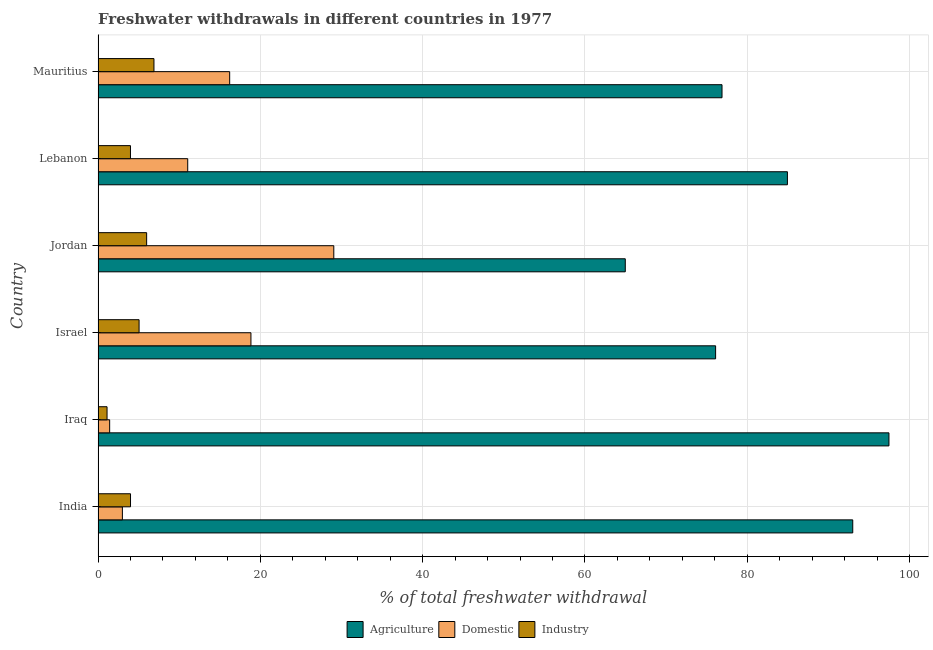How many groups of bars are there?
Offer a very short reply. 6. Are the number of bars per tick equal to the number of legend labels?
Ensure brevity in your answer.  Yes. Are the number of bars on each tick of the Y-axis equal?
Provide a succinct answer. Yes. How many bars are there on the 3rd tick from the bottom?
Offer a terse response. 3. What is the label of the 3rd group of bars from the top?
Ensure brevity in your answer.  Jordan. What is the percentage of freshwater withdrawal for agriculture in Iraq?
Make the answer very short. 97.46. Across all countries, what is the maximum percentage of freshwater withdrawal for industry?
Your response must be concise. 6.89. Across all countries, what is the minimum percentage of freshwater withdrawal for agriculture?
Provide a short and direct response. 64.97. In which country was the percentage of freshwater withdrawal for industry maximum?
Your answer should be very brief. Mauritius. In which country was the percentage of freshwater withdrawal for industry minimum?
Give a very brief answer. Iraq. What is the total percentage of freshwater withdrawal for industry in the graph?
Offer a very short reply. 27.03. What is the difference between the percentage of freshwater withdrawal for industry in India and that in Iraq?
Your answer should be very brief. 2.89. What is the difference between the percentage of freshwater withdrawal for domestic purposes in Iraq and the percentage of freshwater withdrawal for agriculture in India?
Give a very brief answer. -91.57. What is the average percentage of freshwater withdrawal for agriculture per country?
Your answer should be compact. 82.23. What is the difference between the percentage of freshwater withdrawal for domestic purposes and percentage of freshwater withdrawal for agriculture in Mauritius?
Provide a succinct answer. -60.67. In how many countries, is the percentage of freshwater withdrawal for industry greater than 44 %?
Ensure brevity in your answer.  0. What is the ratio of the percentage of freshwater withdrawal for industry in Jordan to that in Mauritius?
Give a very brief answer. 0.87. Is the difference between the percentage of freshwater withdrawal for industry in Lebanon and Mauritius greater than the difference between the percentage of freshwater withdrawal for domestic purposes in Lebanon and Mauritius?
Your answer should be very brief. Yes. What is the difference between the highest and the second highest percentage of freshwater withdrawal for domestic purposes?
Provide a short and direct response. 10.21. What is the difference between the highest and the lowest percentage of freshwater withdrawal for agriculture?
Your answer should be very brief. 32.49. In how many countries, is the percentage of freshwater withdrawal for domestic purposes greater than the average percentage of freshwater withdrawal for domestic purposes taken over all countries?
Provide a short and direct response. 3. Is the sum of the percentage of freshwater withdrawal for agriculture in Iraq and Israel greater than the maximum percentage of freshwater withdrawal for industry across all countries?
Offer a terse response. Yes. What does the 1st bar from the top in Lebanon represents?
Your answer should be very brief. Industry. What does the 2nd bar from the bottom in Israel represents?
Your answer should be compact. Domestic. How many bars are there?
Ensure brevity in your answer.  18. Are all the bars in the graph horizontal?
Ensure brevity in your answer.  Yes. How many countries are there in the graph?
Your answer should be compact. 6. What is the difference between two consecutive major ticks on the X-axis?
Your answer should be very brief. 20. Are the values on the major ticks of X-axis written in scientific E-notation?
Make the answer very short. No. Does the graph contain grids?
Ensure brevity in your answer.  Yes. What is the title of the graph?
Your answer should be very brief. Freshwater withdrawals in different countries in 1977. What is the label or title of the X-axis?
Provide a short and direct response. % of total freshwater withdrawal. What is the % of total freshwater withdrawal of Agriculture in India?
Make the answer very short. 93. What is the % of total freshwater withdrawal of Industry in India?
Keep it short and to the point. 4. What is the % of total freshwater withdrawal in Agriculture in Iraq?
Give a very brief answer. 97.46. What is the % of total freshwater withdrawal in Domestic in Iraq?
Give a very brief answer. 1.43. What is the % of total freshwater withdrawal of Industry in Iraq?
Provide a succinct answer. 1.11. What is the % of total freshwater withdrawal of Agriculture in Israel?
Your response must be concise. 76.1. What is the % of total freshwater withdrawal in Domestic in Israel?
Your answer should be very brief. 18.84. What is the % of total freshwater withdrawal of Industry in Israel?
Offer a very short reply. 5.05. What is the % of total freshwater withdrawal in Agriculture in Jordan?
Make the answer very short. 64.97. What is the % of total freshwater withdrawal in Domestic in Jordan?
Provide a succinct answer. 29.05. What is the % of total freshwater withdrawal of Industry in Jordan?
Give a very brief answer. 5.99. What is the % of total freshwater withdrawal in Agriculture in Lebanon?
Ensure brevity in your answer.  84.95. What is the % of total freshwater withdrawal of Domestic in Lebanon?
Your answer should be compact. 11.05. What is the % of total freshwater withdrawal of Industry in Lebanon?
Your answer should be compact. 4. What is the % of total freshwater withdrawal in Agriculture in Mauritius?
Provide a short and direct response. 76.89. What is the % of total freshwater withdrawal of Domestic in Mauritius?
Your response must be concise. 16.22. What is the % of total freshwater withdrawal in Industry in Mauritius?
Provide a short and direct response. 6.89. Across all countries, what is the maximum % of total freshwater withdrawal in Agriculture?
Provide a short and direct response. 97.46. Across all countries, what is the maximum % of total freshwater withdrawal of Domestic?
Ensure brevity in your answer.  29.05. Across all countries, what is the maximum % of total freshwater withdrawal of Industry?
Your answer should be very brief. 6.89. Across all countries, what is the minimum % of total freshwater withdrawal of Agriculture?
Ensure brevity in your answer.  64.97. Across all countries, what is the minimum % of total freshwater withdrawal in Domestic?
Your response must be concise. 1.43. Across all countries, what is the minimum % of total freshwater withdrawal of Industry?
Offer a very short reply. 1.11. What is the total % of total freshwater withdrawal of Agriculture in the graph?
Ensure brevity in your answer.  493.37. What is the total % of total freshwater withdrawal in Domestic in the graph?
Your answer should be compact. 79.59. What is the total % of total freshwater withdrawal in Industry in the graph?
Your answer should be very brief. 27.04. What is the difference between the % of total freshwater withdrawal of Agriculture in India and that in Iraq?
Your response must be concise. -4.46. What is the difference between the % of total freshwater withdrawal in Domestic in India and that in Iraq?
Your answer should be very brief. 1.57. What is the difference between the % of total freshwater withdrawal in Industry in India and that in Iraq?
Offer a very short reply. 2.89. What is the difference between the % of total freshwater withdrawal in Domestic in India and that in Israel?
Ensure brevity in your answer.  -15.84. What is the difference between the % of total freshwater withdrawal in Industry in India and that in Israel?
Make the answer very short. -1.05. What is the difference between the % of total freshwater withdrawal in Agriculture in India and that in Jordan?
Offer a very short reply. 28.03. What is the difference between the % of total freshwater withdrawal in Domestic in India and that in Jordan?
Ensure brevity in your answer.  -26.05. What is the difference between the % of total freshwater withdrawal in Industry in India and that in Jordan?
Make the answer very short. -1.99. What is the difference between the % of total freshwater withdrawal in Agriculture in India and that in Lebanon?
Your answer should be very brief. 8.05. What is the difference between the % of total freshwater withdrawal in Domestic in India and that in Lebanon?
Ensure brevity in your answer.  -8.05. What is the difference between the % of total freshwater withdrawal of Industry in India and that in Lebanon?
Ensure brevity in your answer.  0.01. What is the difference between the % of total freshwater withdrawal in Agriculture in India and that in Mauritius?
Your response must be concise. 16.11. What is the difference between the % of total freshwater withdrawal in Domestic in India and that in Mauritius?
Offer a very short reply. -13.22. What is the difference between the % of total freshwater withdrawal of Industry in India and that in Mauritius?
Give a very brief answer. -2.89. What is the difference between the % of total freshwater withdrawal of Agriculture in Iraq and that in Israel?
Provide a succinct answer. 21.36. What is the difference between the % of total freshwater withdrawal of Domestic in Iraq and that in Israel?
Your response must be concise. -17.41. What is the difference between the % of total freshwater withdrawal of Industry in Iraq and that in Israel?
Your answer should be very brief. -3.95. What is the difference between the % of total freshwater withdrawal of Agriculture in Iraq and that in Jordan?
Offer a terse response. 32.49. What is the difference between the % of total freshwater withdrawal in Domestic in Iraq and that in Jordan?
Give a very brief answer. -27.62. What is the difference between the % of total freshwater withdrawal of Industry in Iraq and that in Jordan?
Give a very brief answer. -4.88. What is the difference between the % of total freshwater withdrawal in Agriculture in Iraq and that in Lebanon?
Keep it short and to the point. 12.51. What is the difference between the % of total freshwater withdrawal of Domestic in Iraq and that in Lebanon?
Provide a succinct answer. -9.62. What is the difference between the % of total freshwater withdrawal in Industry in Iraq and that in Lebanon?
Offer a terse response. -2.89. What is the difference between the % of total freshwater withdrawal of Agriculture in Iraq and that in Mauritius?
Offer a terse response. 20.57. What is the difference between the % of total freshwater withdrawal of Domestic in Iraq and that in Mauritius?
Keep it short and to the point. -14.79. What is the difference between the % of total freshwater withdrawal of Industry in Iraq and that in Mauritius?
Your answer should be compact. -5.78. What is the difference between the % of total freshwater withdrawal of Agriculture in Israel and that in Jordan?
Make the answer very short. 11.13. What is the difference between the % of total freshwater withdrawal of Domestic in Israel and that in Jordan?
Provide a succinct answer. -10.21. What is the difference between the % of total freshwater withdrawal of Industry in Israel and that in Jordan?
Your response must be concise. -0.93. What is the difference between the % of total freshwater withdrawal of Agriculture in Israel and that in Lebanon?
Your response must be concise. -8.85. What is the difference between the % of total freshwater withdrawal in Domestic in Israel and that in Lebanon?
Ensure brevity in your answer.  7.79. What is the difference between the % of total freshwater withdrawal in Industry in Israel and that in Lebanon?
Provide a succinct answer. 1.06. What is the difference between the % of total freshwater withdrawal of Agriculture in Israel and that in Mauritius?
Your answer should be very brief. -0.79. What is the difference between the % of total freshwater withdrawal in Domestic in Israel and that in Mauritius?
Your answer should be compact. 2.62. What is the difference between the % of total freshwater withdrawal of Industry in Israel and that in Mauritius?
Your answer should be compact. -1.83. What is the difference between the % of total freshwater withdrawal of Agriculture in Jordan and that in Lebanon?
Offer a very short reply. -19.98. What is the difference between the % of total freshwater withdrawal of Domestic in Jordan and that in Lebanon?
Offer a terse response. 18. What is the difference between the % of total freshwater withdrawal in Industry in Jordan and that in Lebanon?
Your answer should be very brief. 1.99. What is the difference between the % of total freshwater withdrawal in Agriculture in Jordan and that in Mauritius?
Give a very brief answer. -11.92. What is the difference between the % of total freshwater withdrawal in Domestic in Jordan and that in Mauritius?
Keep it short and to the point. 12.83. What is the difference between the % of total freshwater withdrawal in Industry in Jordan and that in Mauritius?
Provide a short and direct response. -0.9. What is the difference between the % of total freshwater withdrawal in Agriculture in Lebanon and that in Mauritius?
Your answer should be very brief. 8.06. What is the difference between the % of total freshwater withdrawal in Domestic in Lebanon and that in Mauritius?
Provide a short and direct response. -5.17. What is the difference between the % of total freshwater withdrawal of Industry in Lebanon and that in Mauritius?
Offer a very short reply. -2.89. What is the difference between the % of total freshwater withdrawal of Agriculture in India and the % of total freshwater withdrawal of Domestic in Iraq?
Offer a terse response. 91.57. What is the difference between the % of total freshwater withdrawal of Agriculture in India and the % of total freshwater withdrawal of Industry in Iraq?
Your answer should be compact. 91.89. What is the difference between the % of total freshwater withdrawal of Domestic in India and the % of total freshwater withdrawal of Industry in Iraq?
Make the answer very short. 1.89. What is the difference between the % of total freshwater withdrawal of Agriculture in India and the % of total freshwater withdrawal of Domestic in Israel?
Ensure brevity in your answer.  74.16. What is the difference between the % of total freshwater withdrawal of Agriculture in India and the % of total freshwater withdrawal of Industry in Israel?
Your answer should be very brief. 87.94. What is the difference between the % of total freshwater withdrawal of Domestic in India and the % of total freshwater withdrawal of Industry in Israel?
Offer a very short reply. -2.06. What is the difference between the % of total freshwater withdrawal in Agriculture in India and the % of total freshwater withdrawal in Domestic in Jordan?
Your answer should be compact. 63.95. What is the difference between the % of total freshwater withdrawal in Agriculture in India and the % of total freshwater withdrawal in Industry in Jordan?
Offer a very short reply. 87.01. What is the difference between the % of total freshwater withdrawal in Domestic in India and the % of total freshwater withdrawal in Industry in Jordan?
Ensure brevity in your answer.  -2.99. What is the difference between the % of total freshwater withdrawal of Agriculture in India and the % of total freshwater withdrawal of Domestic in Lebanon?
Your answer should be compact. 81.95. What is the difference between the % of total freshwater withdrawal in Agriculture in India and the % of total freshwater withdrawal in Industry in Lebanon?
Provide a short and direct response. 89. What is the difference between the % of total freshwater withdrawal in Domestic in India and the % of total freshwater withdrawal in Industry in Lebanon?
Ensure brevity in your answer.  -0.99. What is the difference between the % of total freshwater withdrawal in Agriculture in India and the % of total freshwater withdrawal in Domestic in Mauritius?
Your answer should be very brief. 76.78. What is the difference between the % of total freshwater withdrawal of Agriculture in India and the % of total freshwater withdrawal of Industry in Mauritius?
Offer a terse response. 86.11. What is the difference between the % of total freshwater withdrawal of Domestic in India and the % of total freshwater withdrawal of Industry in Mauritius?
Keep it short and to the point. -3.89. What is the difference between the % of total freshwater withdrawal of Agriculture in Iraq and the % of total freshwater withdrawal of Domestic in Israel?
Offer a very short reply. 78.62. What is the difference between the % of total freshwater withdrawal in Agriculture in Iraq and the % of total freshwater withdrawal in Industry in Israel?
Keep it short and to the point. 92.41. What is the difference between the % of total freshwater withdrawal in Domestic in Iraq and the % of total freshwater withdrawal in Industry in Israel?
Give a very brief answer. -3.62. What is the difference between the % of total freshwater withdrawal in Agriculture in Iraq and the % of total freshwater withdrawal in Domestic in Jordan?
Offer a terse response. 68.41. What is the difference between the % of total freshwater withdrawal of Agriculture in Iraq and the % of total freshwater withdrawal of Industry in Jordan?
Ensure brevity in your answer.  91.47. What is the difference between the % of total freshwater withdrawal of Domestic in Iraq and the % of total freshwater withdrawal of Industry in Jordan?
Keep it short and to the point. -4.56. What is the difference between the % of total freshwater withdrawal of Agriculture in Iraq and the % of total freshwater withdrawal of Domestic in Lebanon?
Give a very brief answer. 86.41. What is the difference between the % of total freshwater withdrawal of Agriculture in Iraq and the % of total freshwater withdrawal of Industry in Lebanon?
Provide a short and direct response. 93.47. What is the difference between the % of total freshwater withdrawal in Domestic in Iraq and the % of total freshwater withdrawal in Industry in Lebanon?
Keep it short and to the point. -2.56. What is the difference between the % of total freshwater withdrawal of Agriculture in Iraq and the % of total freshwater withdrawal of Domestic in Mauritius?
Your answer should be very brief. 81.24. What is the difference between the % of total freshwater withdrawal in Agriculture in Iraq and the % of total freshwater withdrawal in Industry in Mauritius?
Offer a terse response. 90.57. What is the difference between the % of total freshwater withdrawal of Domestic in Iraq and the % of total freshwater withdrawal of Industry in Mauritius?
Offer a terse response. -5.46. What is the difference between the % of total freshwater withdrawal in Agriculture in Israel and the % of total freshwater withdrawal in Domestic in Jordan?
Keep it short and to the point. 47.05. What is the difference between the % of total freshwater withdrawal in Agriculture in Israel and the % of total freshwater withdrawal in Industry in Jordan?
Provide a succinct answer. 70.11. What is the difference between the % of total freshwater withdrawal of Domestic in Israel and the % of total freshwater withdrawal of Industry in Jordan?
Your response must be concise. 12.85. What is the difference between the % of total freshwater withdrawal of Agriculture in Israel and the % of total freshwater withdrawal of Domestic in Lebanon?
Your answer should be compact. 65.05. What is the difference between the % of total freshwater withdrawal in Agriculture in Israel and the % of total freshwater withdrawal in Industry in Lebanon?
Provide a succinct answer. 72.11. What is the difference between the % of total freshwater withdrawal of Domestic in Israel and the % of total freshwater withdrawal of Industry in Lebanon?
Offer a terse response. 14.85. What is the difference between the % of total freshwater withdrawal of Agriculture in Israel and the % of total freshwater withdrawal of Domestic in Mauritius?
Your response must be concise. 59.88. What is the difference between the % of total freshwater withdrawal in Agriculture in Israel and the % of total freshwater withdrawal in Industry in Mauritius?
Make the answer very short. 69.21. What is the difference between the % of total freshwater withdrawal in Domestic in Israel and the % of total freshwater withdrawal in Industry in Mauritius?
Provide a short and direct response. 11.95. What is the difference between the % of total freshwater withdrawal of Agriculture in Jordan and the % of total freshwater withdrawal of Domestic in Lebanon?
Your answer should be compact. 53.92. What is the difference between the % of total freshwater withdrawal of Agriculture in Jordan and the % of total freshwater withdrawal of Industry in Lebanon?
Your answer should be compact. 60.98. What is the difference between the % of total freshwater withdrawal in Domestic in Jordan and the % of total freshwater withdrawal in Industry in Lebanon?
Offer a very short reply. 25.05. What is the difference between the % of total freshwater withdrawal of Agriculture in Jordan and the % of total freshwater withdrawal of Domestic in Mauritius?
Your answer should be compact. 48.75. What is the difference between the % of total freshwater withdrawal of Agriculture in Jordan and the % of total freshwater withdrawal of Industry in Mauritius?
Ensure brevity in your answer.  58.08. What is the difference between the % of total freshwater withdrawal of Domestic in Jordan and the % of total freshwater withdrawal of Industry in Mauritius?
Offer a terse response. 22.16. What is the difference between the % of total freshwater withdrawal in Agriculture in Lebanon and the % of total freshwater withdrawal in Domestic in Mauritius?
Offer a terse response. 68.73. What is the difference between the % of total freshwater withdrawal of Agriculture in Lebanon and the % of total freshwater withdrawal of Industry in Mauritius?
Your answer should be compact. 78.06. What is the difference between the % of total freshwater withdrawal in Domestic in Lebanon and the % of total freshwater withdrawal in Industry in Mauritius?
Offer a terse response. 4.16. What is the average % of total freshwater withdrawal of Agriculture per country?
Keep it short and to the point. 82.23. What is the average % of total freshwater withdrawal of Domestic per country?
Ensure brevity in your answer.  13.27. What is the average % of total freshwater withdrawal in Industry per country?
Make the answer very short. 4.51. What is the difference between the % of total freshwater withdrawal of Agriculture and % of total freshwater withdrawal of Domestic in India?
Offer a very short reply. 90. What is the difference between the % of total freshwater withdrawal in Agriculture and % of total freshwater withdrawal in Industry in India?
Your answer should be very brief. 89. What is the difference between the % of total freshwater withdrawal of Domestic and % of total freshwater withdrawal of Industry in India?
Make the answer very short. -1. What is the difference between the % of total freshwater withdrawal in Agriculture and % of total freshwater withdrawal in Domestic in Iraq?
Your answer should be compact. 96.03. What is the difference between the % of total freshwater withdrawal in Agriculture and % of total freshwater withdrawal in Industry in Iraq?
Offer a very short reply. 96.35. What is the difference between the % of total freshwater withdrawal of Domestic and % of total freshwater withdrawal of Industry in Iraq?
Offer a terse response. 0.32. What is the difference between the % of total freshwater withdrawal of Agriculture and % of total freshwater withdrawal of Domestic in Israel?
Provide a succinct answer. 57.26. What is the difference between the % of total freshwater withdrawal of Agriculture and % of total freshwater withdrawal of Industry in Israel?
Make the answer very short. 71.05. What is the difference between the % of total freshwater withdrawal of Domestic and % of total freshwater withdrawal of Industry in Israel?
Keep it short and to the point. 13.79. What is the difference between the % of total freshwater withdrawal of Agriculture and % of total freshwater withdrawal of Domestic in Jordan?
Offer a very short reply. 35.92. What is the difference between the % of total freshwater withdrawal in Agriculture and % of total freshwater withdrawal in Industry in Jordan?
Ensure brevity in your answer.  58.98. What is the difference between the % of total freshwater withdrawal of Domestic and % of total freshwater withdrawal of Industry in Jordan?
Give a very brief answer. 23.06. What is the difference between the % of total freshwater withdrawal in Agriculture and % of total freshwater withdrawal in Domestic in Lebanon?
Your answer should be very brief. 73.9. What is the difference between the % of total freshwater withdrawal in Agriculture and % of total freshwater withdrawal in Industry in Lebanon?
Your answer should be very brief. 80.95. What is the difference between the % of total freshwater withdrawal in Domestic and % of total freshwater withdrawal in Industry in Lebanon?
Make the answer very short. 7.05. What is the difference between the % of total freshwater withdrawal in Agriculture and % of total freshwater withdrawal in Domestic in Mauritius?
Ensure brevity in your answer.  60.67. What is the difference between the % of total freshwater withdrawal in Agriculture and % of total freshwater withdrawal in Industry in Mauritius?
Make the answer very short. 70. What is the difference between the % of total freshwater withdrawal of Domestic and % of total freshwater withdrawal of Industry in Mauritius?
Your answer should be compact. 9.33. What is the ratio of the % of total freshwater withdrawal of Agriculture in India to that in Iraq?
Your response must be concise. 0.95. What is the ratio of the % of total freshwater withdrawal in Domestic in India to that in Iraq?
Offer a very short reply. 2.1. What is the ratio of the % of total freshwater withdrawal in Industry in India to that in Iraq?
Your answer should be very brief. 3.61. What is the ratio of the % of total freshwater withdrawal of Agriculture in India to that in Israel?
Your response must be concise. 1.22. What is the ratio of the % of total freshwater withdrawal in Domestic in India to that in Israel?
Offer a terse response. 0.16. What is the ratio of the % of total freshwater withdrawal of Industry in India to that in Israel?
Offer a very short reply. 0.79. What is the ratio of the % of total freshwater withdrawal of Agriculture in India to that in Jordan?
Offer a very short reply. 1.43. What is the ratio of the % of total freshwater withdrawal in Domestic in India to that in Jordan?
Offer a terse response. 0.1. What is the ratio of the % of total freshwater withdrawal in Industry in India to that in Jordan?
Make the answer very short. 0.67. What is the ratio of the % of total freshwater withdrawal of Agriculture in India to that in Lebanon?
Offer a very short reply. 1.09. What is the ratio of the % of total freshwater withdrawal of Domestic in India to that in Lebanon?
Make the answer very short. 0.27. What is the ratio of the % of total freshwater withdrawal in Agriculture in India to that in Mauritius?
Give a very brief answer. 1.21. What is the ratio of the % of total freshwater withdrawal of Domestic in India to that in Mauritius?
Provide a short and direct response. 0.18. What is the ratio of the % of total freshwater withdrawal in Industry in India to that in Mauritius?
Ensure brevity in your answer.  0.58. What is the ratio of the % of total freshwater withdrawal in Agriculture in Iraq to that in Israel?
Give a very brief answer. 1.28. What is the ratio of the % of total freshwater withdrawal in Domestic in Iraq to that in Israel?
Ensure brevity in your answer.  0.08. What is the ratio of the % of total freshwater withdrawal of Industry in Iraq to that in Israel?
Your answer should be compact. 0.22. What is the ratio of the % of total freshwater withdrawal in Agriculture in Iraq to that in Jordan?
Make the answer very short. 1.5. What is the ratio of the % of total freshwater withdrawal of Domestic in Iraq to that in Jordan?
Your answer should be very brief. 0.05. What is the ratio of the % of total freshwater withdrawal in Industry in Iraq to that in Jordan?
Make the answer very short. 0.19. What is the ratio of the % of total freshwater withdrawal in Agriculture in Iraq to that in Lebanon?
Provide a short and direct response. 1.15. What is the ratio of the % of total freshwater withdrawal of Domestic in Iraq to that in Lebanon?
Your answer should be very brief. 0.13. What is the ratio of the % of total freshwater withdrawal of Industry in Iraq to that in Lebanon?
Make the answer very short. 0.28. What is the ratio of the % of total freshwater withdrawal in Agriculture in Iraq to that in Mauritius?
Give a very brief answer. 1.27. What is the ratio of the % of total freshwater withdrawal of Domestic in Iraq to that in Mauritius?
Offer a terse response. 0.09. What is the ratio of the % of total freshwater withdrawal in Industry in Iraq to that in Mauritius?
Your answer should be very brief. 0.16. What is the ratio of the % of total freshwater withdrawal of Agriculture in Israel to that in Jordan?
Provide a succinct answer. 1.17. What is the ratio of the % of total freshwater withdrawal in Domestic in Israel to that in Jordan?
Your answer should be compact. 0.65. What is the ratio of the % of total freshwater withdrawal in Industry in Israel to that in Jordan?
Keep it short and to the point. 0.84. What is the ratio of the % of total freshwater withdrawal of Agriculture in Israel to that in Lebanon?
Your answer should be compact. 0.9. What is the ratio of the % of total freshwater withdrawal in Domestic in Israel to that in Lebanon?
Provide a short and direct response. 1.71. What is the ratio of the % of total freshwater withdrawal in Industry in Israel to that in Lebanon?
Provide a short and direct response. 1.27. What is the ratio of the % of total freshwater withdrawal in Domestic in Israel to that in Mauritius?
Your answer should be very brief. 1.16. What is the ratio of the % of total freshwater withdrawal of Industry in Israel to that in Mauritius?
Give a very brief answer. 0.73. What is the ratio of the % of total freshwater withdrawal of Agriculture in Jordan to that in Lebanon?
Offer a terse response. 0.76. What is the ratio of the % of total freshwater withdrawal of Domestic in Jordan to that in Lebanon?
Ensure brevity in your answer.  2.63. What is the ratio of the % of total freshwater withdrawal of Industry in Jordan to that in Lebanon?
Provide a succinct answer. 1.5. What is the ratio of the % of total freshwater withdrawal in Agriculture in Jordan to that in Mauritius?
Ensure brevity in your answer.  0.84. What is the ratio of the % of total freshwater withdrawal in Domestic in Jordan to that in Mauritius?
Keep it short and to the point. 1.79. What is the ratio of the % of total freshwater withdrawal of Industry in Jordan to that in Mauritius?
Keep it short and to the point. 0.87. What is the ratio of the % of total freshwater withdrawal of Agriculture in Lebanon to that in Mauritius?
Give a very brief answer. 1.1. What is the ratio of the % of total freshwater withdrawal of Domestic in Lebanon to that in Mauritius?
Your answer should be very brief. 0.68. What is the ratio of the % of total freshwater withdrawal of Industry in Lebanon to that in Mauritius?
Ensure brevity in your answer.  0.58. What is the difference between the highest and the second highest % of total freshwater withdrawal in Agriculture?
Your response must be concise. 4.46. What is the difference between the highest and the second highest % of total freshwater withdrawal of Domestic?
Offer a very short reply. 10.21. What is the difference between the highest and the second highest % of total freshwater withdrawal in Industry?
Ensure brevity in your answer.  0.9. What is the difference between the highest and the lowest % of total freshwater withdrawal in Agriculture?
Ensure brevity in your answer.  32.49. What is the difference between the highest and the lowest % of total freshwater withdrawal in Domestic?
Your response must be concise. 27.62. What is the difference between the highest and the lowest % of total freshwater withdrawal in Industry?
Provide a succinct answer. 5.78. 